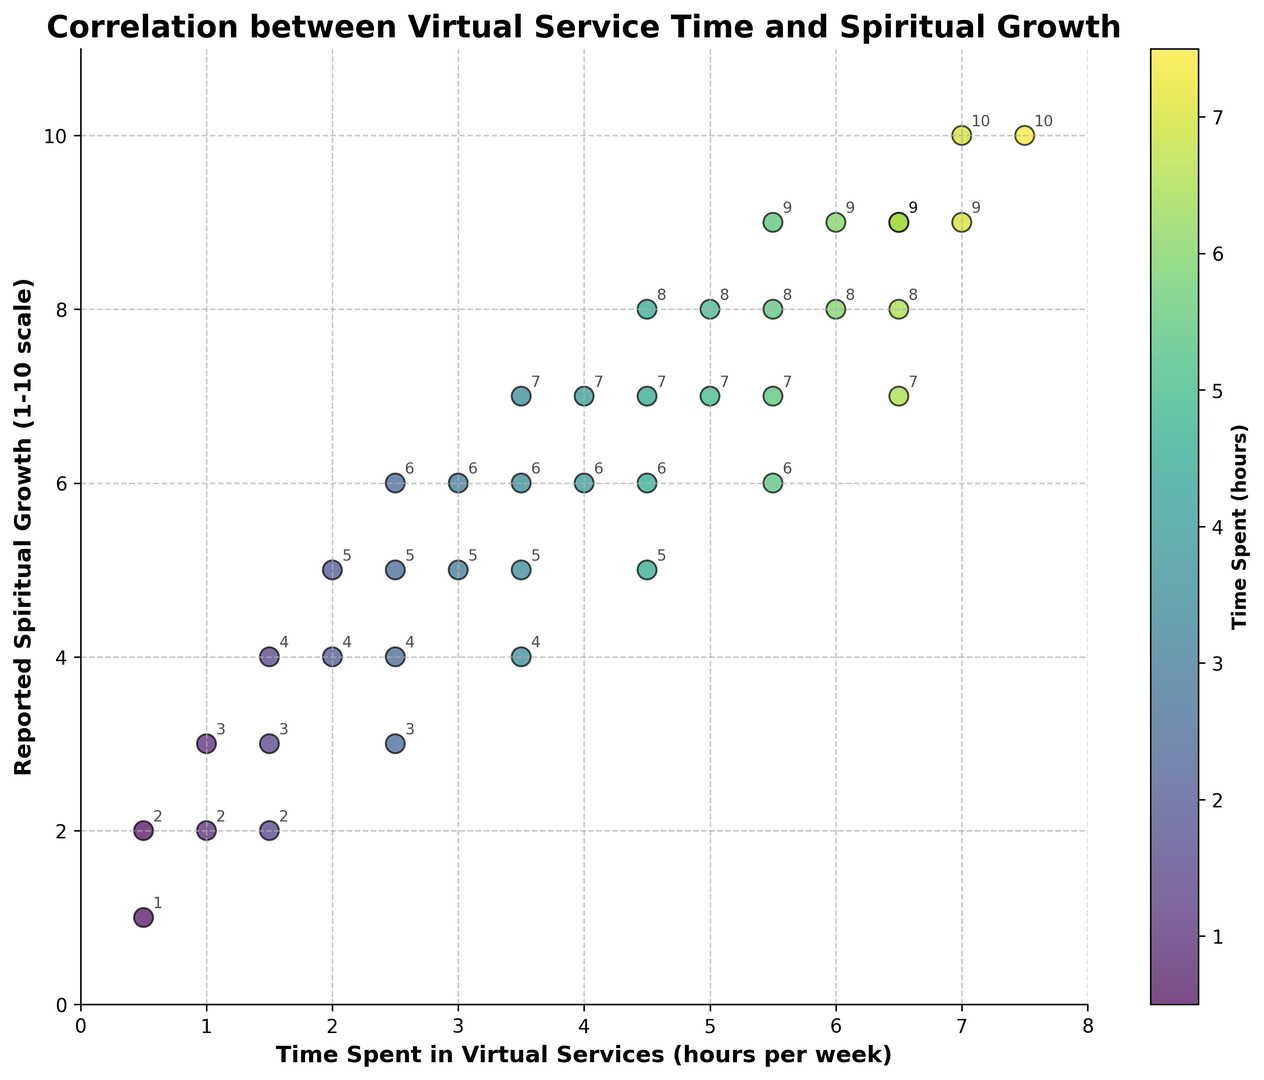What is the range of reported spiritual growth for those who spend around 3 hours per week in virtual services? To find the range, identify the minimum and maximum values of reported spiritual growth for data points where time spent is approximately 3 hours. The points closest to 3 hours are 3, 3, 3.5, and 3.5 hours which have reported spiritual growth values of 5, 5, 6, and 6, respectively. Therefore, the range is from 5 to 6.
Answer: 5 to 6 What is the color of the points that represent 6 hours per week in virtual services? The scatter plot uses a color gradient to represent the time spent in virtual services. Points representing 6 hours per week are colored in a yellowish shade. They stand out distinctively on the gradient from dark to light.
Answer: Yellowish Which time spent category shows the most variation in reported spiritual growth? To determine the category, observe the range of reported spiritual growth values for each time spent interval. Comparing visually, around 0.5 hours per week, the reported spiritual growth varies from 1 to 2, showing the most variation.
Answer: 0.5 hours per week What is the median reported spiritual growth for those who spend 4-5 hours per week in virtual services? The points between 4 and 5 hours per week have reported spiritual growth values of 6, 7, 8, and 8. To find the median, sort these values in ascending order (6, 7, 8, 8) and then take the average of the middle two values: (7 + 8) / 2 = 7.5
Answer: 7.5 Is there a general trend observed between the time spent in virtual services and reported spiritual growth? By observing the scatter plot, you can see that as the time spent in virtual services increases, the reported spiritual growth generally increases too, indicating a positive correlation.
Answer: Positive correlation For values where the reported spiritual growth is 6, what is the distribution of time spent in virtual services? Find the points where the reported spiritual growth is 6. These points show time spent values of 2.5, 3, 3.5, and 4 hours per week, indicating the distribution.
Answer: 2.5, 3, 3.5, 4 hours per week What is the effect on reported spiritual growth for every hour increase in virtual service time between 5 and 6 hours? Between 5 and 6 hours of virtual service time, the reported spiritual growth increases from 7 to 8. Therefore, for each hour increase in time, the reported spiritual growth goes up by 1 point.
Answer: 1 point Which data points are outliers if any? An outlier would be a data point that significantly deviates from the general trend. From visual inspection, there doesn't appear to be a clear outlier as the points generally follow the positive correlation without significant deviation.
Answer: None What are the values of reported spiritual growth for those who spend 1.5 hours per week in virtual services? Identify the points where the time spent is 1.5 hours per week. These points have reported spiritual growth values of 2, 3, and 4.
Answer: 2, 3, 4 